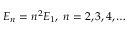<formula> <loc_0><loc_0><loc_500><loc_500>E _ { n } = n ^ { 2 } E _ { 1 } , \, n = 2 , 3 , 4 , \dots</formula> 